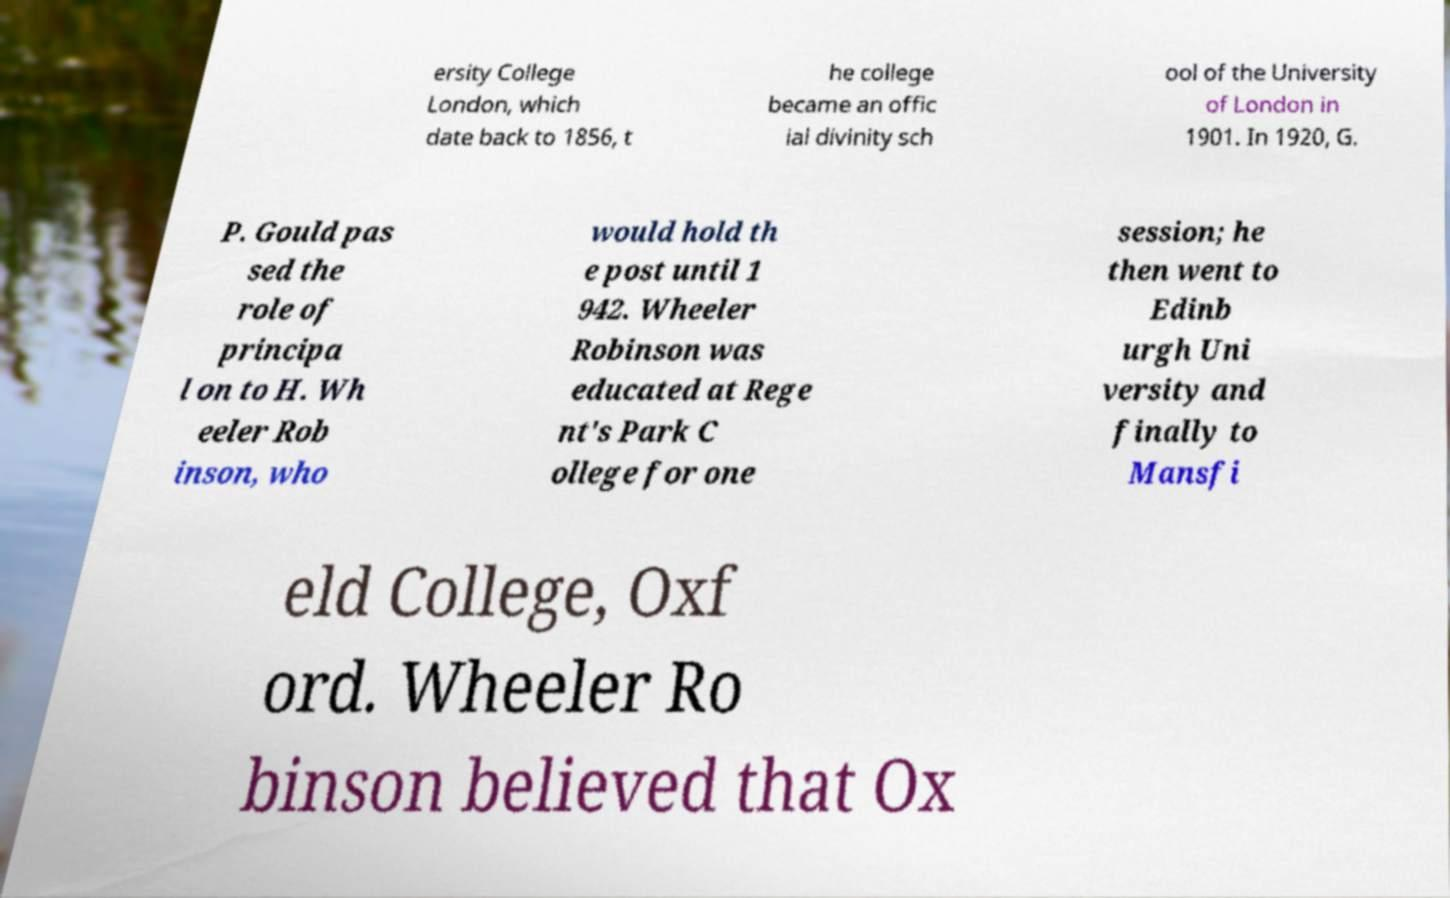Can you read and provide the text displayed in the image?This photo seems to have some interesting text. Can you extract and type it out for me? ersity College London, which date back to 1856, t he college became an offic ial divinity sch ool of the University of London in 1901. In 1920, G. P. Gould pas sed the role of principa l on to H. Wh eeler Rob inson, who would hold th e post until 1 942. Wheeler Robinson was educated at Rege nt's Park C ollege for one session; he then went to Edinb urgh Uni versity and finally to Mansfi eld College, Oxf ord. Wheeler Ro binson believed that Ox 